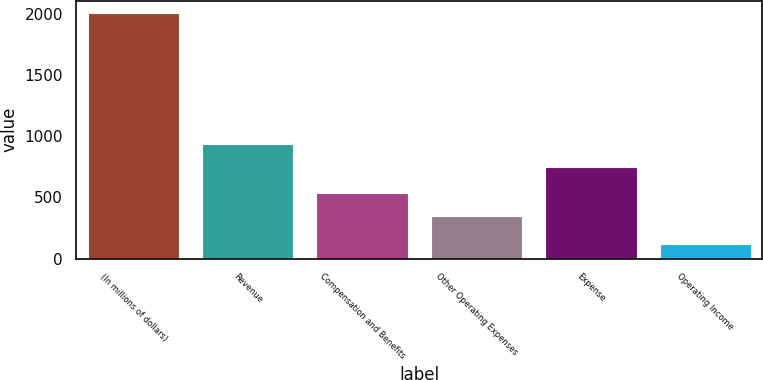Convert chart to OTSL. <chart><loc_0><loc_0><loc_500><loc_500><bar_chart><fcel>(In millions of dollars)<fcel>Revenue<fcel>Compensation and Benefits<fcel>Other Operating Expenses<fcel>Expense<fcel>Operating Income<nl><fcel>2005<fcel>939.4<fcel>533.4<fcel>345<fcel>751<fcel>121<nl></chart> 